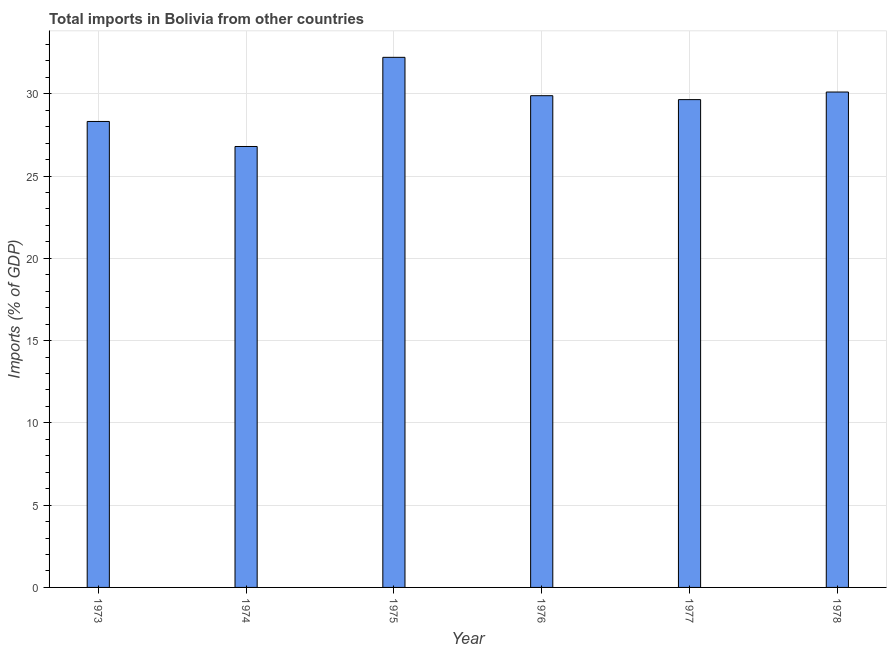What is the title of the graph?
Keep it short and to the point. Total imports in Bolivia from other countries. What is the label or title of the X-axis?
Your answer should be very brief. Year. What is the label or title of the Y-axis?
Keep it short and to the point. Imports (% of GDP). What is the total imports in 1977?
Offer a very short reply. 29.65. Across all years, what is the maximum total imports?
Keep it short and to the point. 32.22. Across all years, what is the minimum total imports?
Make the answer very short. 26.8. In which year was the total imports maximum?
Keep it short and to the point. 1975. In which year was the total imports minimum?
Offer a terse response. 1974. What is the sum of the total imports?
Make the answer very short. 176.97. What is the difference between the total imports in 1973 and 1974?
Ensure brevity in your answer.  1.52. What is the average total imports per year?
Your answer should be compact. 29.5. What is the median total imports?
Give a very brief answer. 29.77. In how many years, is the total imports greater than 8 %?
Your answer should be very brief. 6. Is the total imports in 1977 less than that in 1978?
Make the answer very short. Yes. Is the difference between the total imports in 1974 and 1978 greater than the difference between any two years?
Give a very brief answer. No. What is the difference between the highest and the second highest total imports?
Your response must be concise. 2.11. What is the difference between the highest and the lowest total imports?
Ensure brevity in your answer.  5.42. In how many years, is the total imports greater than the average total imports taken over all years?
Make the answer very short. 4. How many bars are there?
Offer a very short reply. 6. Are all the bars in the graph horizontal?
Ensure brevity in your answer.  No. What is the difference between two consecutive major ticks on the Y-axis?
Your answer should be very brief. 5. Are the values on the major ticks of Y-axis written in scientific E-notation?
Your answer should be very brief. No. What is the Imports (% of GDP) in 1973?
Your answer should be very brief. 28.32. What is the Imports (% of GDP) in 1974?
Your answer should be compact. 26.8. What is the Imports (% of GDP) in 1975?
Your answer should be very brief. 32.22. What is the Imports (% of GDP) of 1976?
Make the answer very short. 29.89. What is the Imports (% of GDP) of 1977?
Your response must be concise. 29.65. What is the Imports (% of GDP) in 1978?
Your answer should be very brief. 30.11. What is the difference between the Imports (% of GDP) in 1973 and 1974?
Offer a very short reply. 1.52. What is the difference between the Imports (% of GDP) in 1973 and 1975?
Make the answer very short. -3.9. What is the difference between the Imports (% of GDP) in 1973 and 1976?
Provide a succinct answer. -1.57. What is the difference between the Imports (% of GDP) in 1973 and 1977?
Provide a succinct answer. -1.33. What is the difference between the Imports (% of GDP) in 1973 and 1978?
Your response must be concise. -1.79. What is the difference between the Imports (% of GDP) in 1974 and 1975?
Your answer should be very brief. -5.42. What is the difference between the Imports (% of GDP) in 1974 and 1976?
Keep it short and to the point. -3.09. What is the difference between the Imports (% of GDP) in 1974 and 1977?
Your answer should be compact. -2.85. What is the difference between the Imports (% of GDP) in 1974 and 1978?
Keep it short and to the point. -3.31. What is the difference between the Imports (% of GDP) in 1975 and 1976?
Give a very brief answer. 2.33. What is the difference between the Imports (% of GDP) in 1975 and 1977?
Your answer should be compact. 2.57. What is the difference between the Imports (% of GDP) in 1975 and 1978?
Your response must be concise. 2.11. What is the difference between the Imports (% of GDP) in 1976 and 1977?
Offer a terse response. 0.24. What is the difference between the Imports (% of GDP) in 1976 and 1978?
Make the answer very short. -0.22. What is the difference between the Imports (% of GDP) in 1977 and 1978?
Provide a succinct answer. -0.46. What is the ratio of the Imports (% of GDP) in 1973 to that in 1974?
Ensure brevity in your answer.  1.06. What is the ratio of the Imports (% of GDP) in 1973 to that in 1975?
Your answer should be compact. 0.88. What is the ratio of the Imports (% of GDP) in 1973 to that in 1976?
Your response must be concise. 0.95. What is the ratio of the Imports (% of GDP) in 1973 to that in 1977?
Make the answer very short. 0.95. What is the ratio of the Imports (% of GDP) in 1973 to that in 1978?
Offer a terse response. 0.94. What is the ratio of the Imports (% of GDP) in 1974 to that in 1975?
Your answer should be very brief. 0.83. What is the ratio of the Imports (% of GDP) in 1974 to that in 1976?
Your response must be concise. 0.9. What is the ratio of the Imports (% of GDP) in 1974 to that in 1977?
Your answer should be very brief. 0.9. What is the ratio of the Imports (% of GDP) in 1974 to that in 1978?
Ensure brevity in your answer.  0.89. What is the ratio of the Imports (% of GDP) in 1975 to that in 1976?
Give a very brief answer. 1.08. What is the ratio of the Imports (% of GDP) in 1975 to that in 1977?
Make the answer very short. 1.09. What is the ratio of the Imports (% of GDP) in 1975 to that in 1978?
Your response must be concise. 1.07. What is the ratio of the Imports (% of GDP) in 1976 to that in 1977?
Give a very brief answer. 1.01. What is the ratio of the Imports (% of GDP) in 1976 to that in 1978?
Offer a terse response. 0.99. 